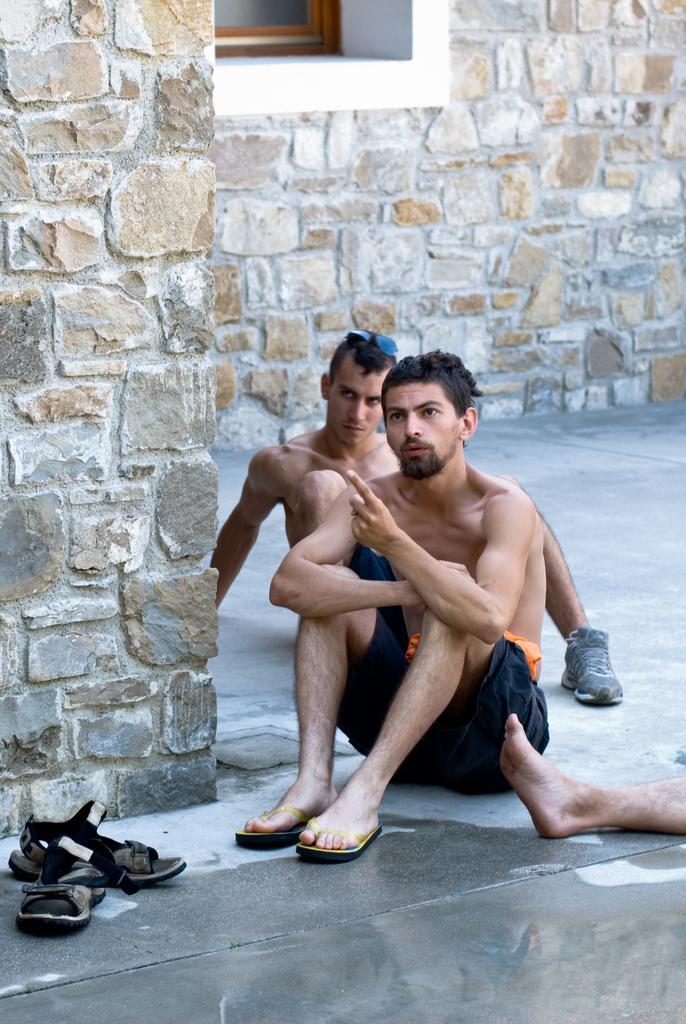Please provide a concise description of this image. In this image few persons are sitting on the floor. Behind there is a wall having a window. Left bottom there is footwear on the floor. Right side a person's leg is visible. 